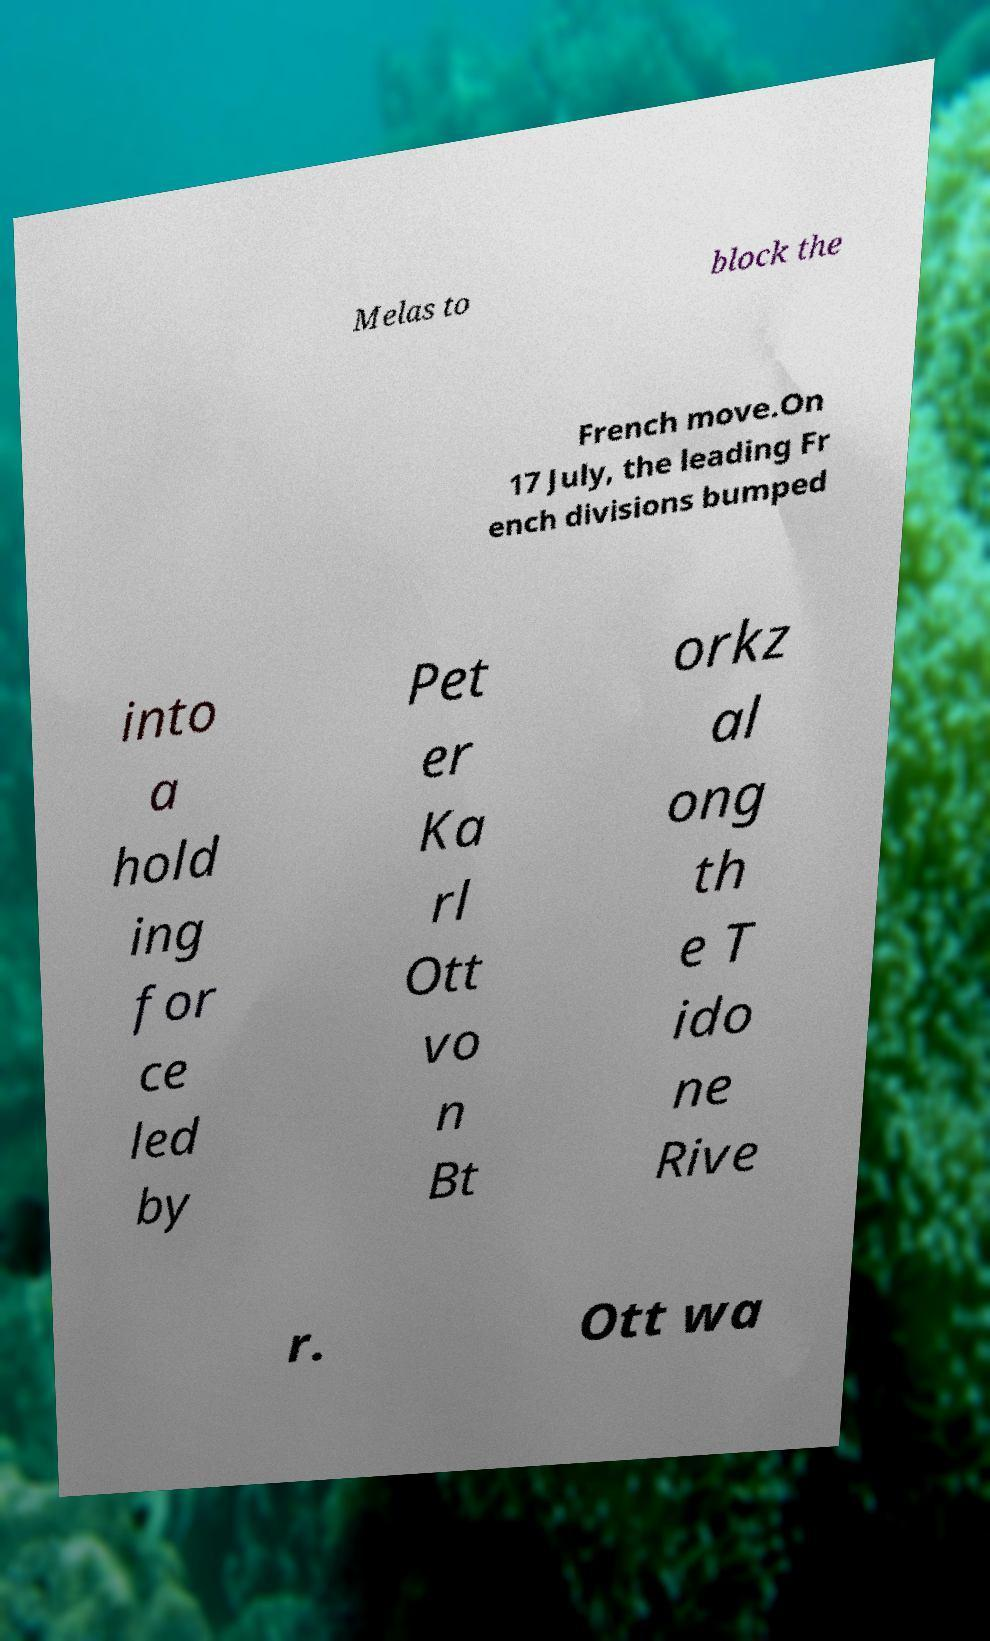Could you assist in decoding the text presented in this image and type it out clearly? Melas to block the French move.On 17 July, the leading Fr ench divisions bumped into a hold ing for ce led by Pet er Ka rl Ott vo n Bt orkz al ong th e T ido ne Rive r. Ott wa 